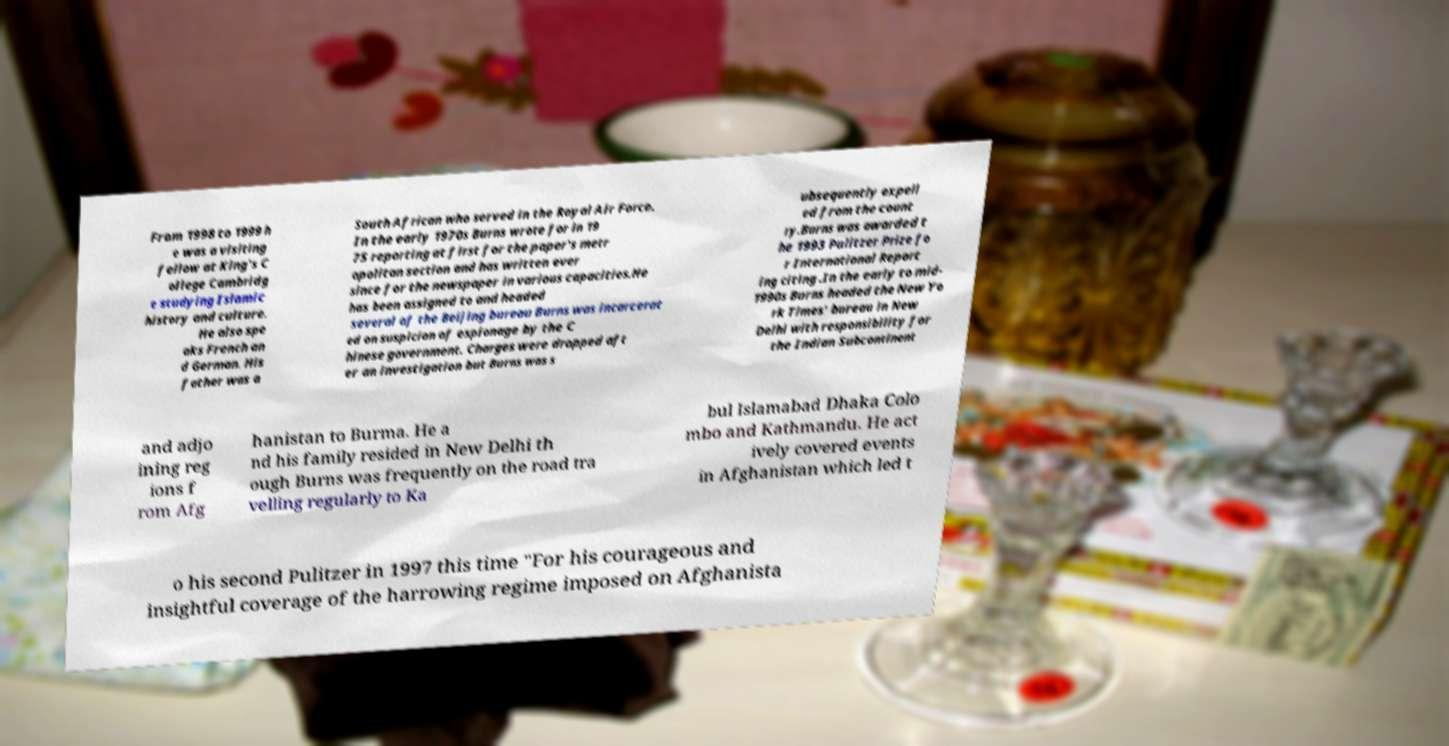Can you accurately transcribe the text from the provided image for me? From 1998 to 1999 h e was a visiting fellow at King's C ollege Cambridg e studying Islamic history and culture. He also spe aks French an d German. His father was a South African who served in the Royal Air Force. In the early 1970s Burns wrote for in 19 75 reporting at first for the paper's metr opolitan section and has written ever since for the newspaper in various capacities.He has been assigned to and headed several of the Beijing bureau Burns was incarcerat ed on suspicion of espionage by the C hinese government. Charges were dropped aft er an investigation but Burns was s ubsequently expell ed from the count ry.Burns was awarded t he 1993 Pulitzer Prize fo r International Report ing citing .In the early to mid- 1990s Burns headed the New Yo rk Times' bureau in New Delhi with responsibility for the Indian Subcontinent and adjo ining reg ions f rom Afg hanistan to Burma. He a nd his family resided in New Delhi th ough Burns was frequently on the road tra velling regularly to Ka bul Islamabad Dhaka Colo mbo and Kathmandu. He act ively covered events in Afghanistan which led t o his second Pulitzer in 1997 this time "For his courageous and insightful coverage of the harrowing regime imposed on Afghanista 